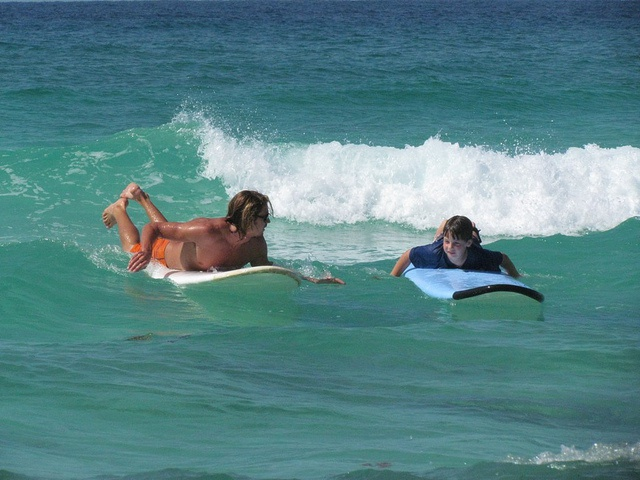Describe the objects in this image and their specific colors. I can see people in gray, brown, black, and maroon tones, people in gray, black, navy, and blue tones, surfboard in gray, lightblue, and black tones, and surfboard in gray, teal, lightgray, and darkgray tones in this image. 